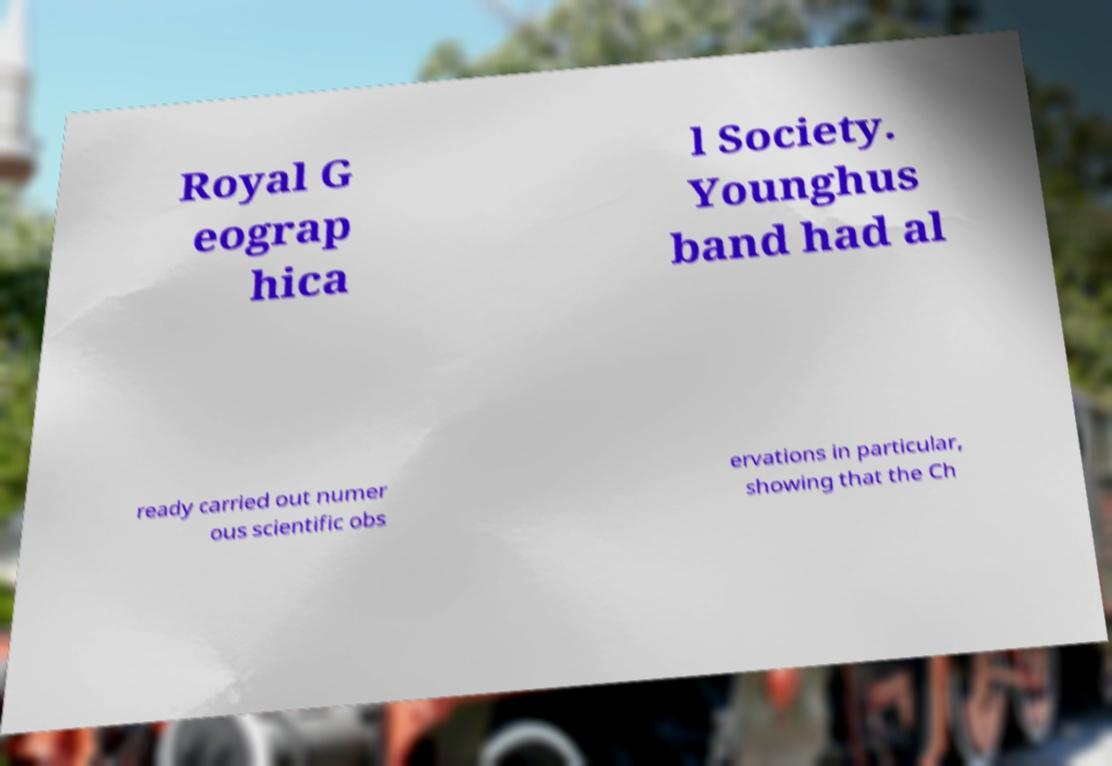Could you assist in decoding the text presented in this image and type it out clearly? Royal G eograp hica l Society. Younghus band had al ready carried out numer ous scientific obs ervations in particular, showing that the Ch 